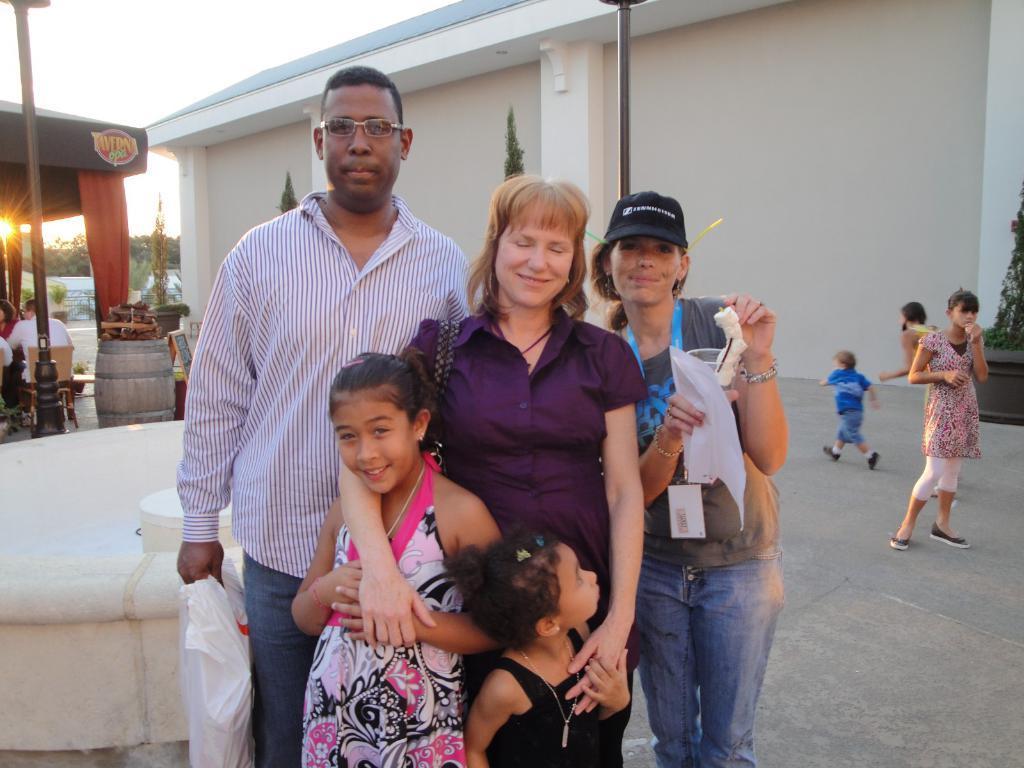Can you describe this image briefly? In this image we can see a man wearing the glasses and holding the cover and standing. We can also see the women and kids. In the background we can see the trees, house, poles, path and also some objects. We can also see the sky and also the sun. On the left, we can see the tent for shelter. We can also see a person sitting on the chair. 